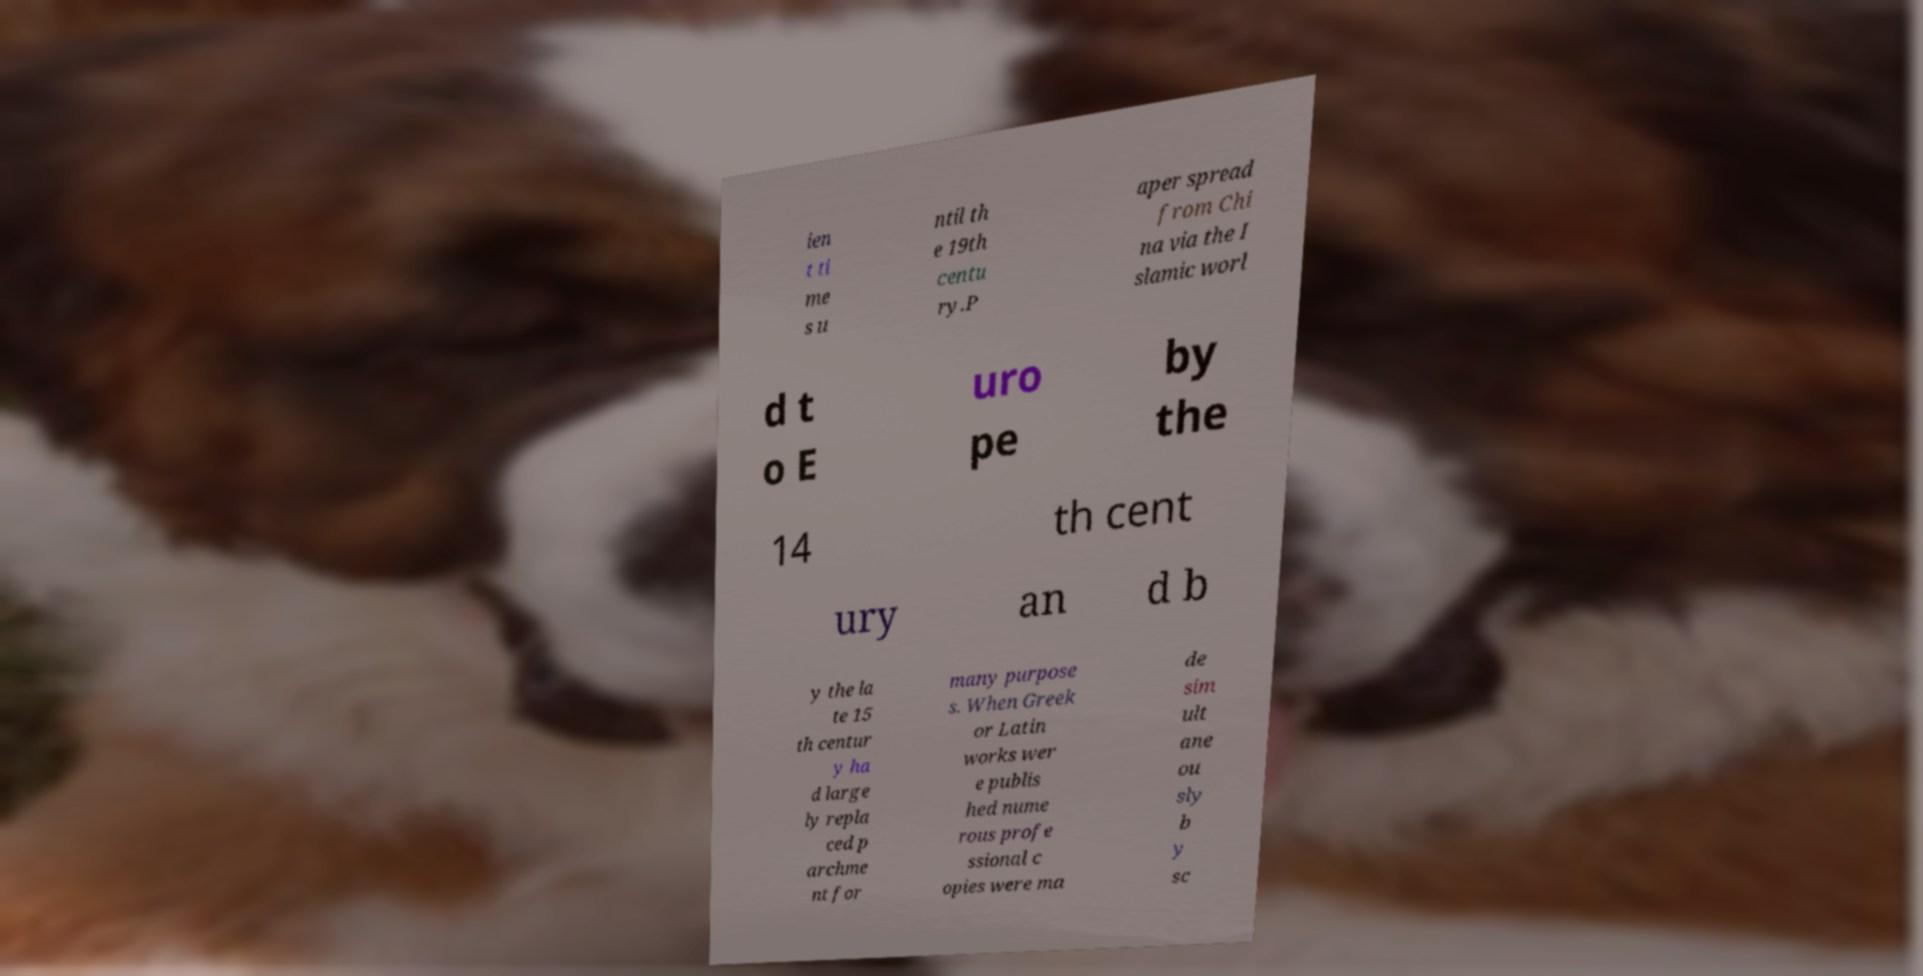Can you read and provide the text displayed in the image?This photo seems to have some interesting text. Can you extract and type it out for me? ien t ti me s u ntil th e 19th centu ry.P aper spread from Chi na via the I slamic worl d t o E uro pe by the 14 th cent ury an d b y the la te 15 th centur y ha d large ly repla ced p archme nt for many purpose s. When Greek or Latin works wer e publis hed nume rous profe ssional c opies were ma de sim ult ane ou sly b y sc 